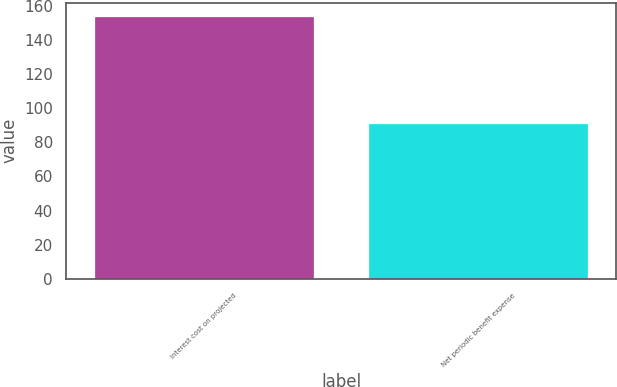Convert chart. <chart><loc_0><loc_0><loc_500><loc_500><bar_chart><fcel>Interest cost on projected<fcel>Net periodic benefit expense<nl><fcel>154<fcel>91<nl></chart> 